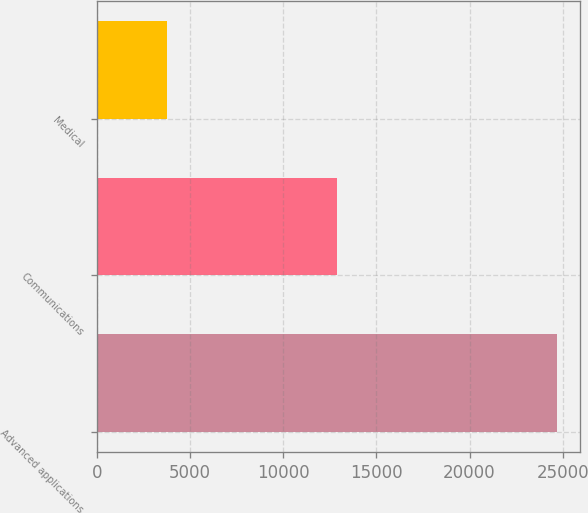Convert chart. <chart><loc_0><loc_0><loc_500><loc_500><bar_chart><fcel>Advanced applications<fcel>Communications<fcel>Medical<nl><fcel>24670<fcel>12904<fcel>3782<nl></chart> 